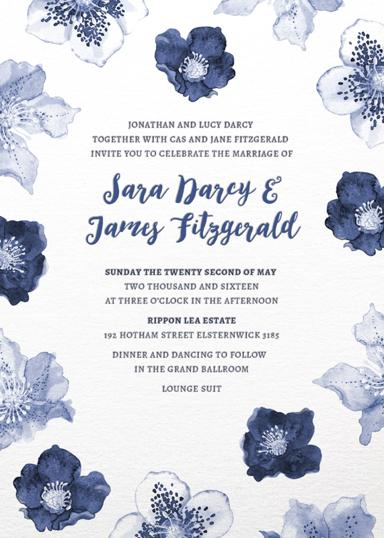When and where does the wedding take place? The wedding of Sara Darcy and James Fitzgerald is scheduled for Sunday, May 22, 2016, at the picturesque Rippon Lea Estate located at 192 Hotham Street, Elsternwick. The ceremony will start at three in the afternoon, promising an elegant setting for their special day. 